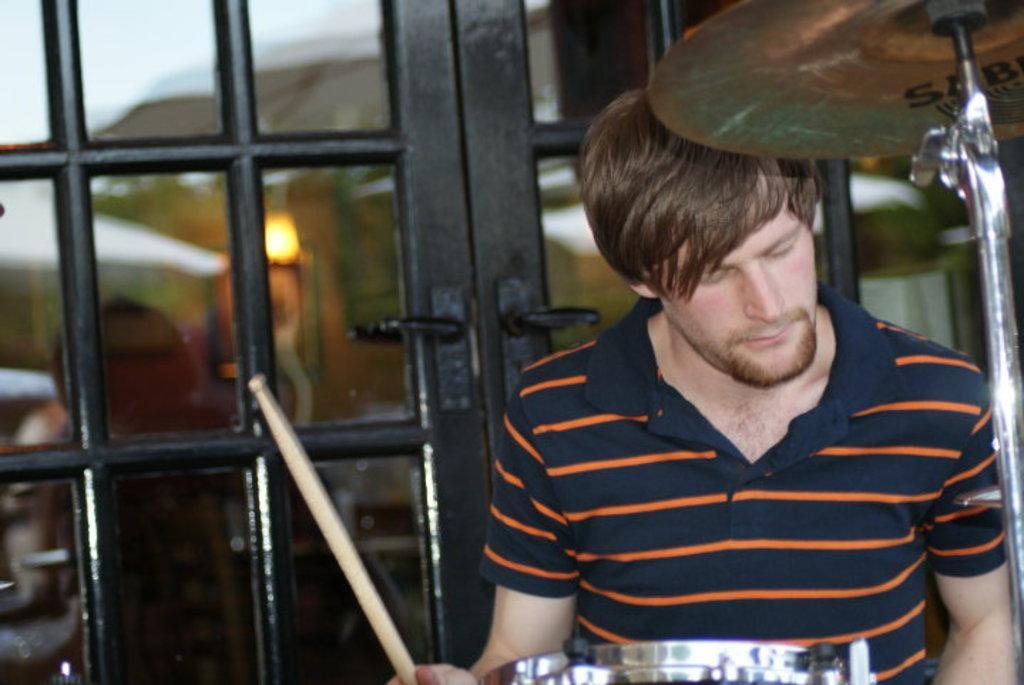Please provide a concise description of this image. In this image a person is standing playing drums and behind him I can see doors. This person is wearing Striped T shirt. 